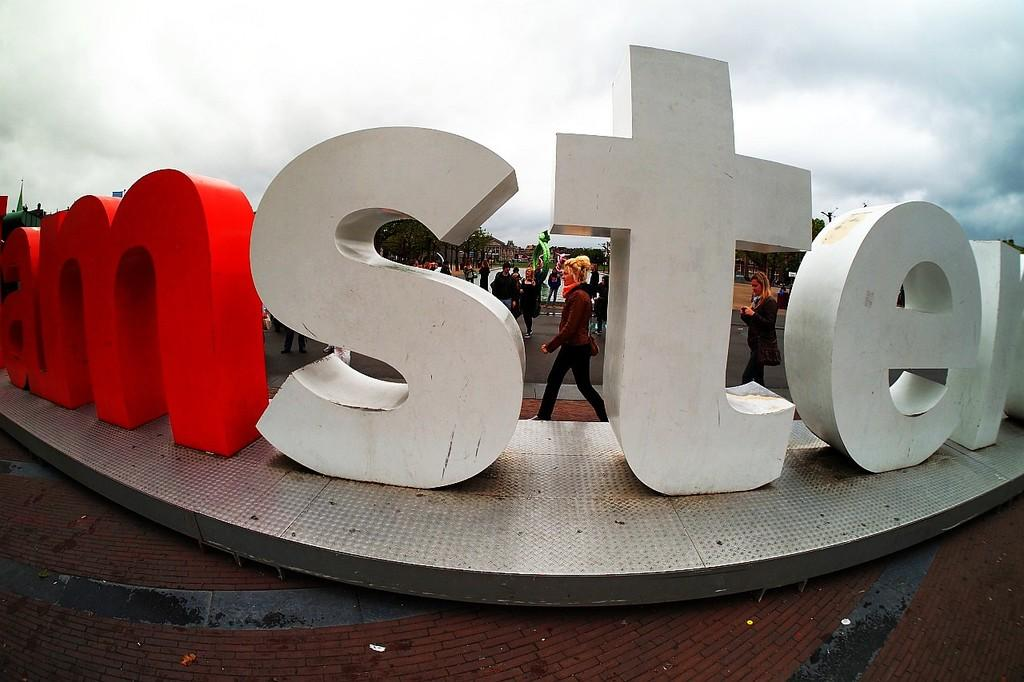What is happening in the image? There is a group of people standing on the ground, and there are buildings, trees, and a statue present. Can you describe the setting of the image? The image features buildings, trees, and a statue, and there is some text in the foreground. The sky is visible in the background, and it appears to be cloudy. How many people are in the group? The number of people in the group is not specified, but there is a group of people standing on the ground. What is the statue of? The facts provided do not specify what the statue is of. How does the table feel about the ongoing battle in the image? There is no table or battle present in the image. The image features a group of people standing on the ground, buildings, trees, a statue, and some text in the foreground, with a cloudy sky visible in the background. 